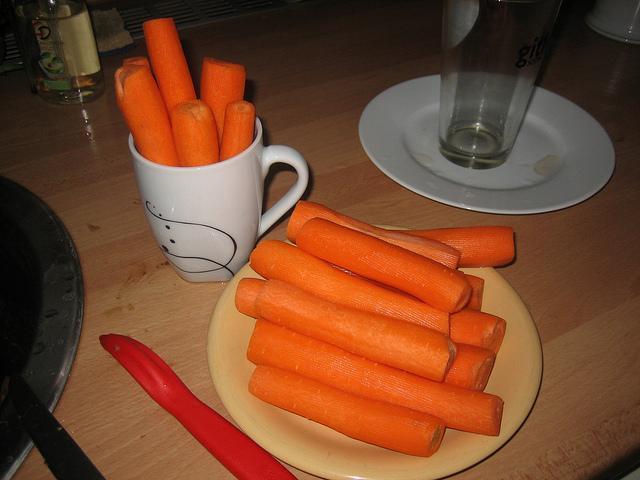How many knives can be seen?
Give a very brief answer. 2. How many carrots are there?
Give a very brief answer. 5. How many cups are in the photo?
Give a very brief answer. 2. 